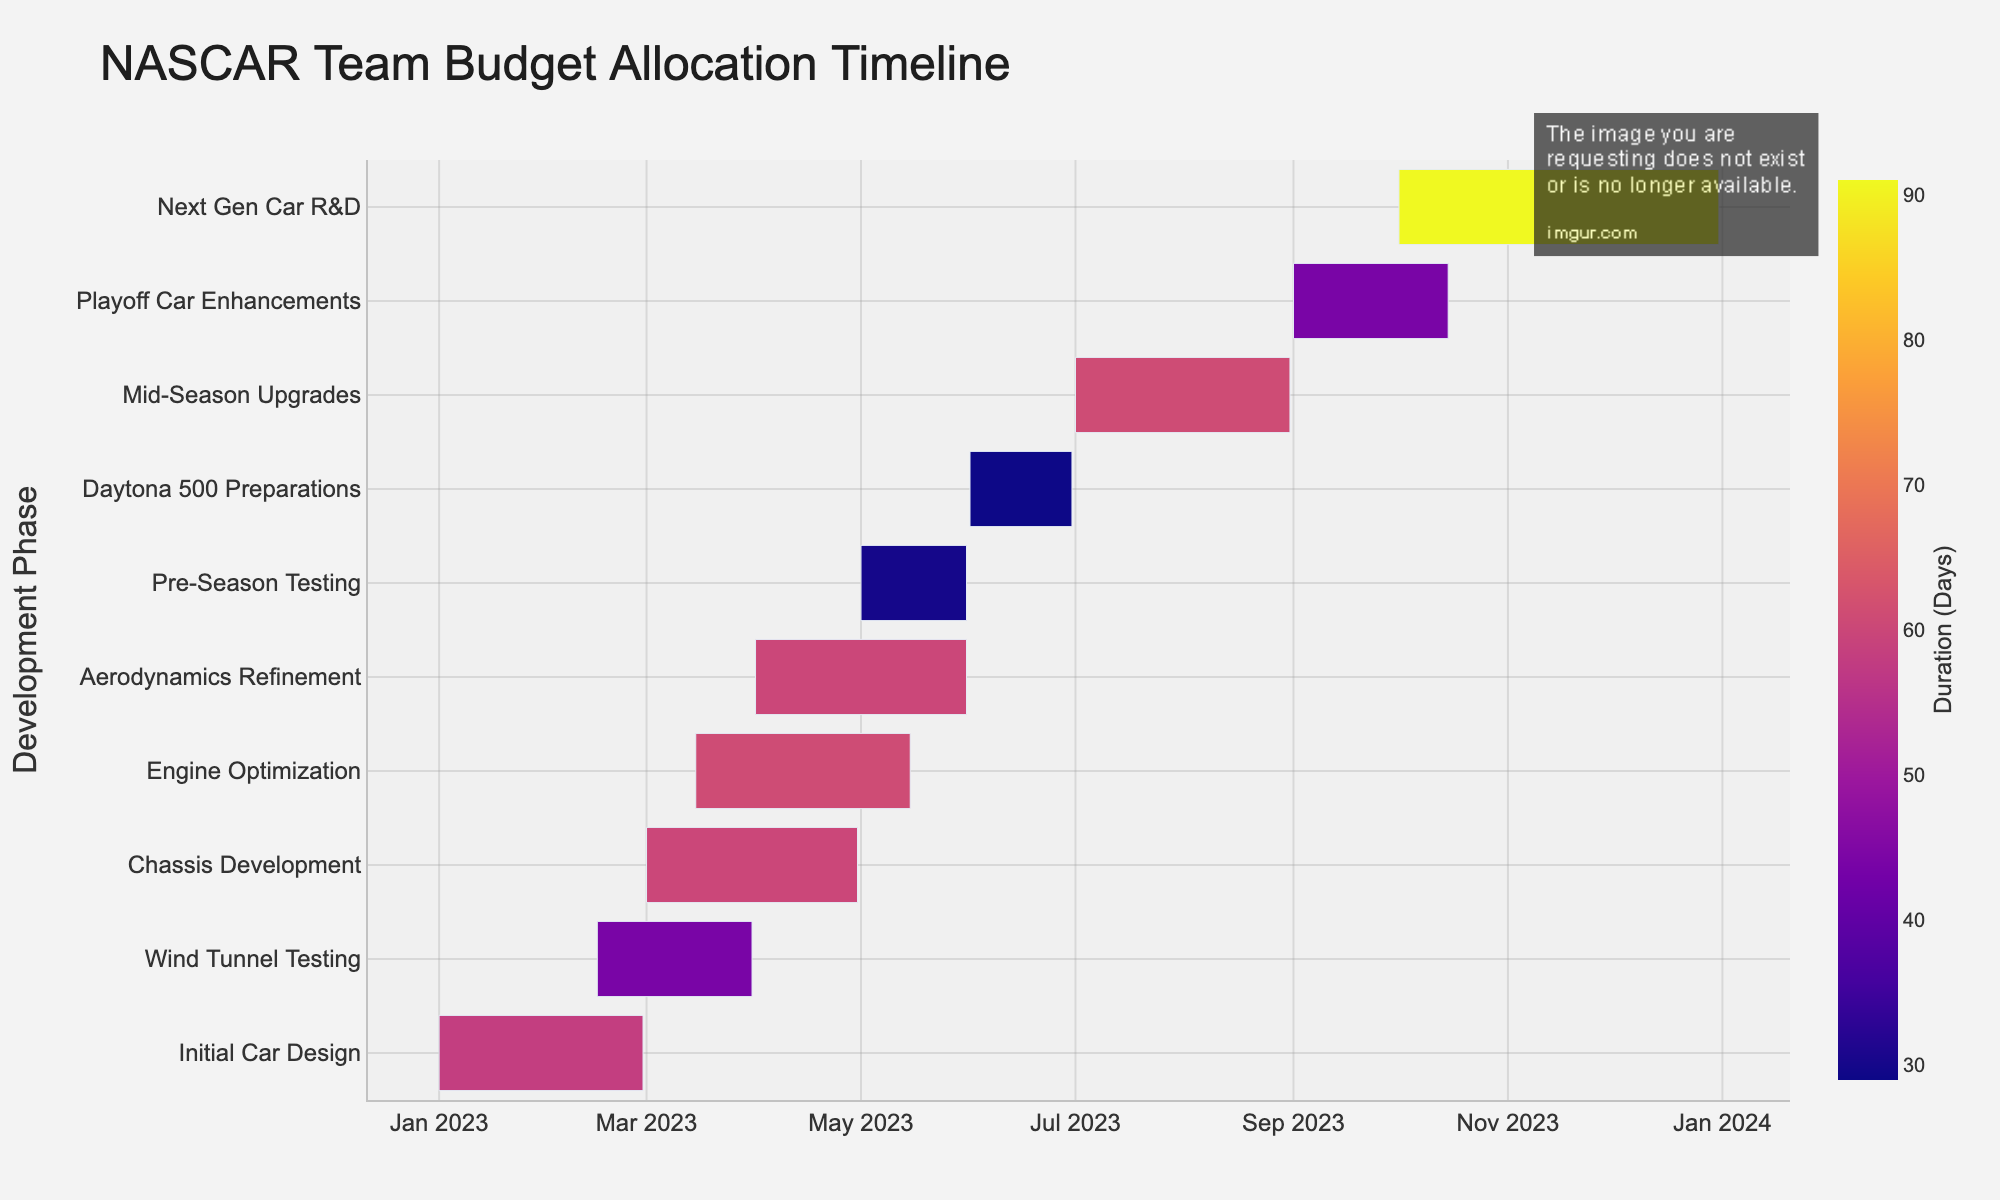What's the title of the Gantt chart? The title of the chart is displayed at the top, usually in a larger font size and prominently positioned.
Answer: NASCAR Team Budget Allocation Timeline When does the Initial Car Design phase start and end? Locate the "Initial Car Design" task in the Gantt chart and refer to its corresponding start and end dates on the x-axis.
Answer: 2023-01-01 to 2023-02-28 Which task has the longest duration? By comparing the duration of each task visually, the task with the longest bar represents the longest duration.
Answer: Next Gen Car R&D How many tasks are scheduled to start in March 2023? Review the starting points of each task on the x-axis to identify which ones begin in March 2023.
Answer: Three tasks (Chassis Development, Engine Optimization, Aerodynamics Refinement) Which task overlaps with Wind Tunnel Testing and by how many days does this overlap occur? Observe the section where the Wind Tunnel Testing bar overlaps with other tasks’ bars and calculate the overlapping days. Wind Tunnel Testing overlaps with Chassis Development and Initial Car Design. Overlaps can be determined by visual counting. Let's take the beginning overlap with Chassis Development as primary for specific overlap days.
Answer: Chassis Development; 31 days Which phase directly follows Pre-Season Testing? Identify and compare the end date of Pre-Season Testing to the start date of subsequent phases on the timeline.
Answer: Daytona 500 Preparations What is the total duration from the start of the Initial Car Design to the end of the Pre-Season Testing? Find the start date of Initial Car Design and the end date of Pre-Season Testing, then calculate the difference between these dates using the Gantt chart's x-axis timeline.
Answer: 2023-01-01 to 2023-05-31, 151 days Compare the durations of Aerodynamics Refinement and Mid-Season Upgrades. Which is shorter? Check the duration of both tasks as indicated by the length of their respective bars and compare the numerical values.
Answer: Aerodynamics Refinement How many tasks are planned to finish in December 2023? Examine the end dates of each task to see which ones conclude in December 2023, according to the Gantt chart.
Answer: One task (Next Gen Car R&D) 